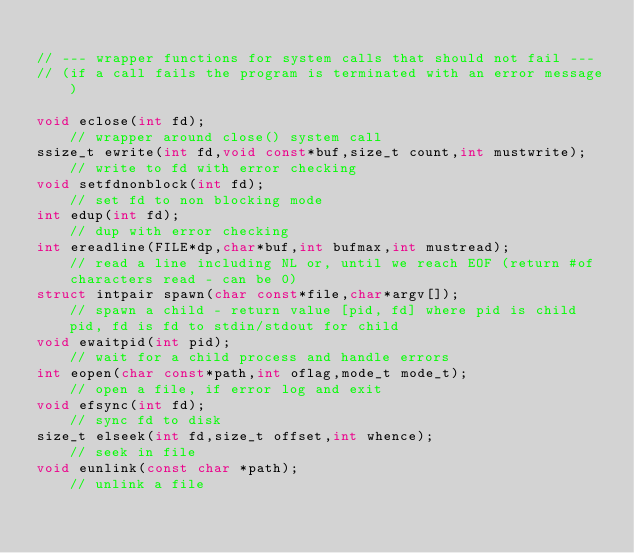<code> <loc_0><loc_0><loc_500><loc_500><_C_>
// --- wrapper functions for system calls that should not fail ---
// (if a call fails the program is terminated with an error message)

void eclose(int fd);                                              // wrapper around close() system call
ssize_t ewrite(int fd,void const*buf,size_t count,int mustwrite); // write to fd with error checking
void setfdnonblock(int fd);                                       // set fd to non blocking mode
int edup(int fd);                                                 // dup with error checking
int ereadline(FILE*dp,char*buf,int bufmax,int mustread);          // read a line including NL or, until we reach EOF (return #of characters read - can be 0)
struct intpair spawn(char const*file,char*argv[]);                // spawn a child - return value [pid, fd] where pid is child pid, fd is fd to stdin/stdout for child
void ewaitpid(int pid);                                           // wait for a child process and handle errors
int eopen(char const*path,int oflag,mode_t mode_t);               // open a file, if error log and exit
void efsync(int fd);                                              // sync fd to disk
size_t elseek(int fd,size_t offset,int whence);                   // seek in file
void eunlink(const char *path);                                   // unlink a file
</code> 